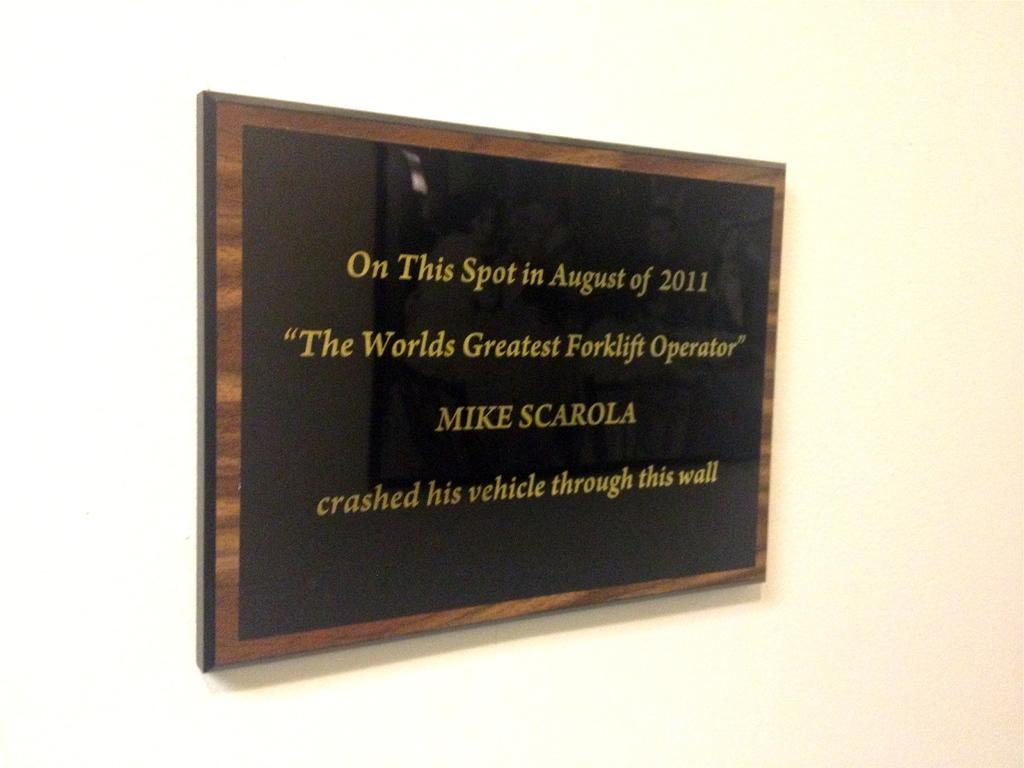<image>
Present a compact description of the photo's key features. A sign that tells everyone that Mike Scarola crashed his vehicle through that wall. 